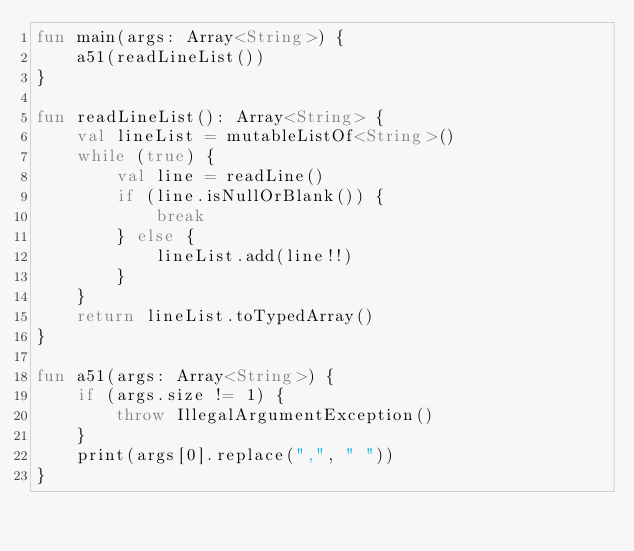Convert code to text. <code><loc_0><loc_0><loc_500><loc_500><_Kotlin_>fun main(args: Array<String>) {
    a51(readLineList())
}

fun readLineList(): Array<String> {
    val lineList = mutableListOf<String>()
    while (true) {
        val line = readLine()
        if (line.isNullOrBlank()) {
            break
        } else {
            lineList.add(line!!)
        }
    }
    return lineList.toTypedArray()
}

fun a51(args: Array<String>) {
    if (args.size != 1) {
        throw IllegalArgumentException()
    }
    print(args[0].replace(",", " "))
}</code> 